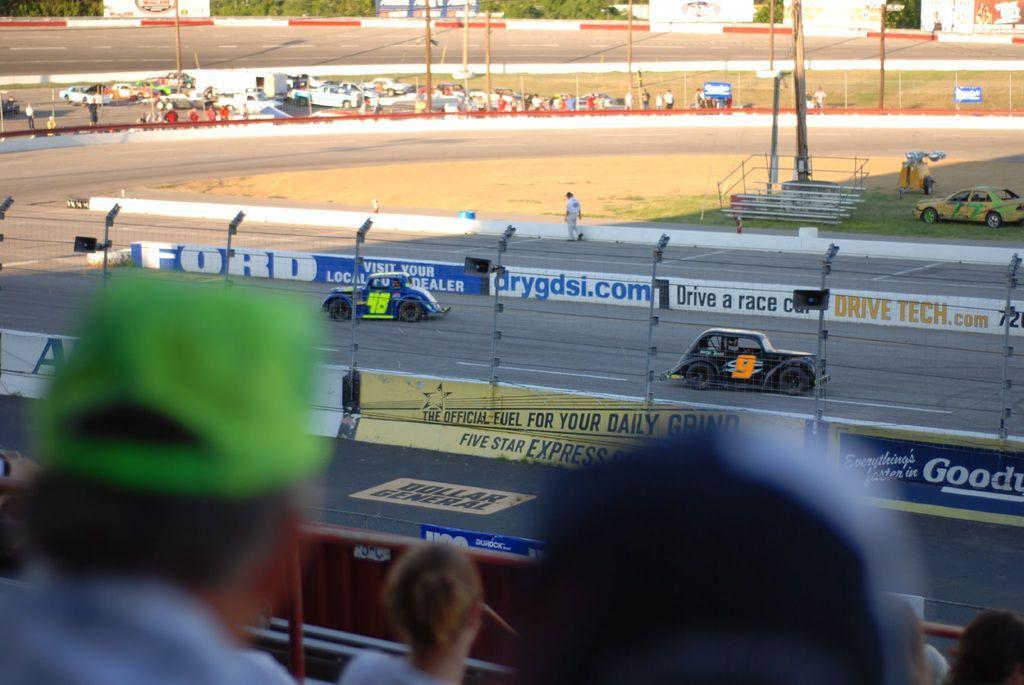How would you summarize this image in a sentence or two? In the center of the image we can see vehicles on the road. At the bottom we can see lights, persons and fencing. In the background there is a car, poles, vehicles, road and trees. 